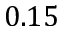<formula> <loc_0><loc_0><loc_500><loc_500>0 . 1 5</formula> 